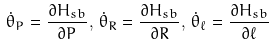<formula> <loc_0><loc_0><loc_500><loc_500>\dot { \theta } _ { P } = \frac { \partial H _ { s b } } { \partial P } , \, \dot { \theta } _ { R } = \frac { \partial H _ { s b } } { \partial R } , \, \dot { \theta } _ { \ell } = \frac { \partial H _ { s b } } { \partial \ell }</formula> 